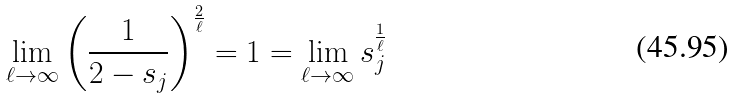<formula> <loc_0><loc_0><loc_500><loc_500>\lim _ { \ell \rightarrow \infty } \left ( \frac { 1 } { 2 - s _ { j } } \right ) ^ { \frac { 2 } { \ell } } = 1 = \lim _ { \ell \rightarrow \infty } s _ { j } ^ { \frac { 1 } { \ell } }</formula> 